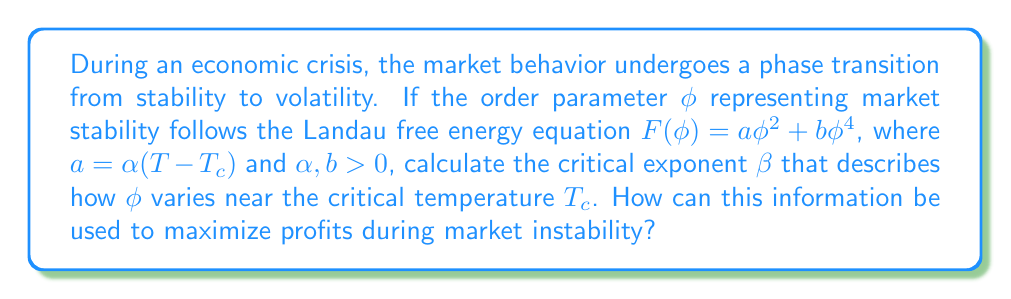What is the answer to this math problem? 1. The Landau free energy equation is given by:
   $$F(\phi) = a\phi^2 + b\phi^4$$
   where $a = \alpha(T - T_c)$

2. At equilibrium, we minimize $F(\phi)$ with respect to $\phi$:
   $$\frac{dF}{d\phi} = 2a\phi + 4b\phi^3 = 0$$

3. Solving for non-zero $\phi$:
   $$2a\phi + 4b\phi^3 = 0$$
   $$\phi^2 = -\frac{a}{2b} = -\frac{\alpha(T - T_c)}{2b}$$

4. For $T < T_c$, we have:
   $$\phi = \pm \sqrt{\frac{\alpha(T_c - T)}{2b}}$$

5. Near the critical temperature, we can approximate:
   $$\phi \propto (T_c - T)^\beta$$

6. Comparing with our solution, we see that $\beta = \frac{1}{2}$

7. This critical exponent describes how the order parameter (market stability) changes near the phase transition point.

8. To maximize profits during market instability:
   - Recognize that market volatility increases sharply as $T$ approaches $T_c$
   - Implement high-frequency trading strategies to capitalize on rapid price fluctuations
   - Increase short-term positions and reduce long-term holdings
   - Utilize derivatives and options to hedge against extreme market movements
Answer: $\beta = \frac{1}{2}$; Implement high-frequency trading and increase short-term positions. 